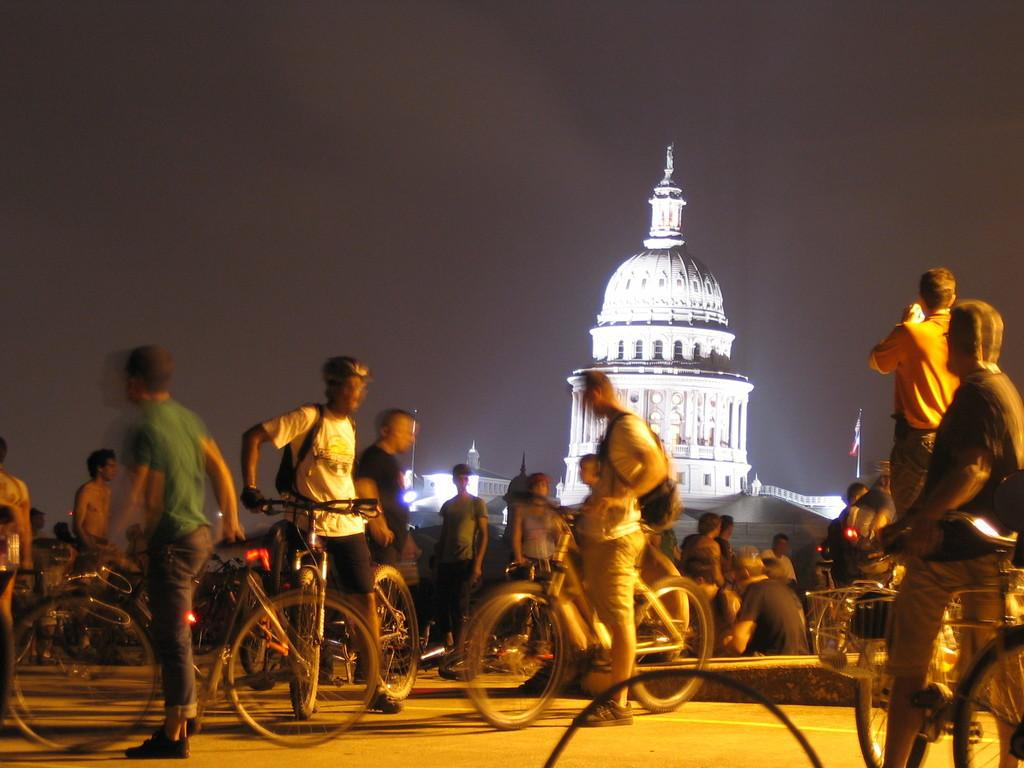How many people are present in the image? There are many people in the image. What are the people doing in the image? The people are with bicycles. What can be seen in the background of the image? There is a building, sky, and a flag visible in the background of the image. What type of egg is being used to roll down the hill in the image? There is no egg or rolling activity present in the image. What is the stem of the bicycle used for in the image? Bicycles do not have stems; they have handlebars and pedals, which are used for steering and propulsion. 